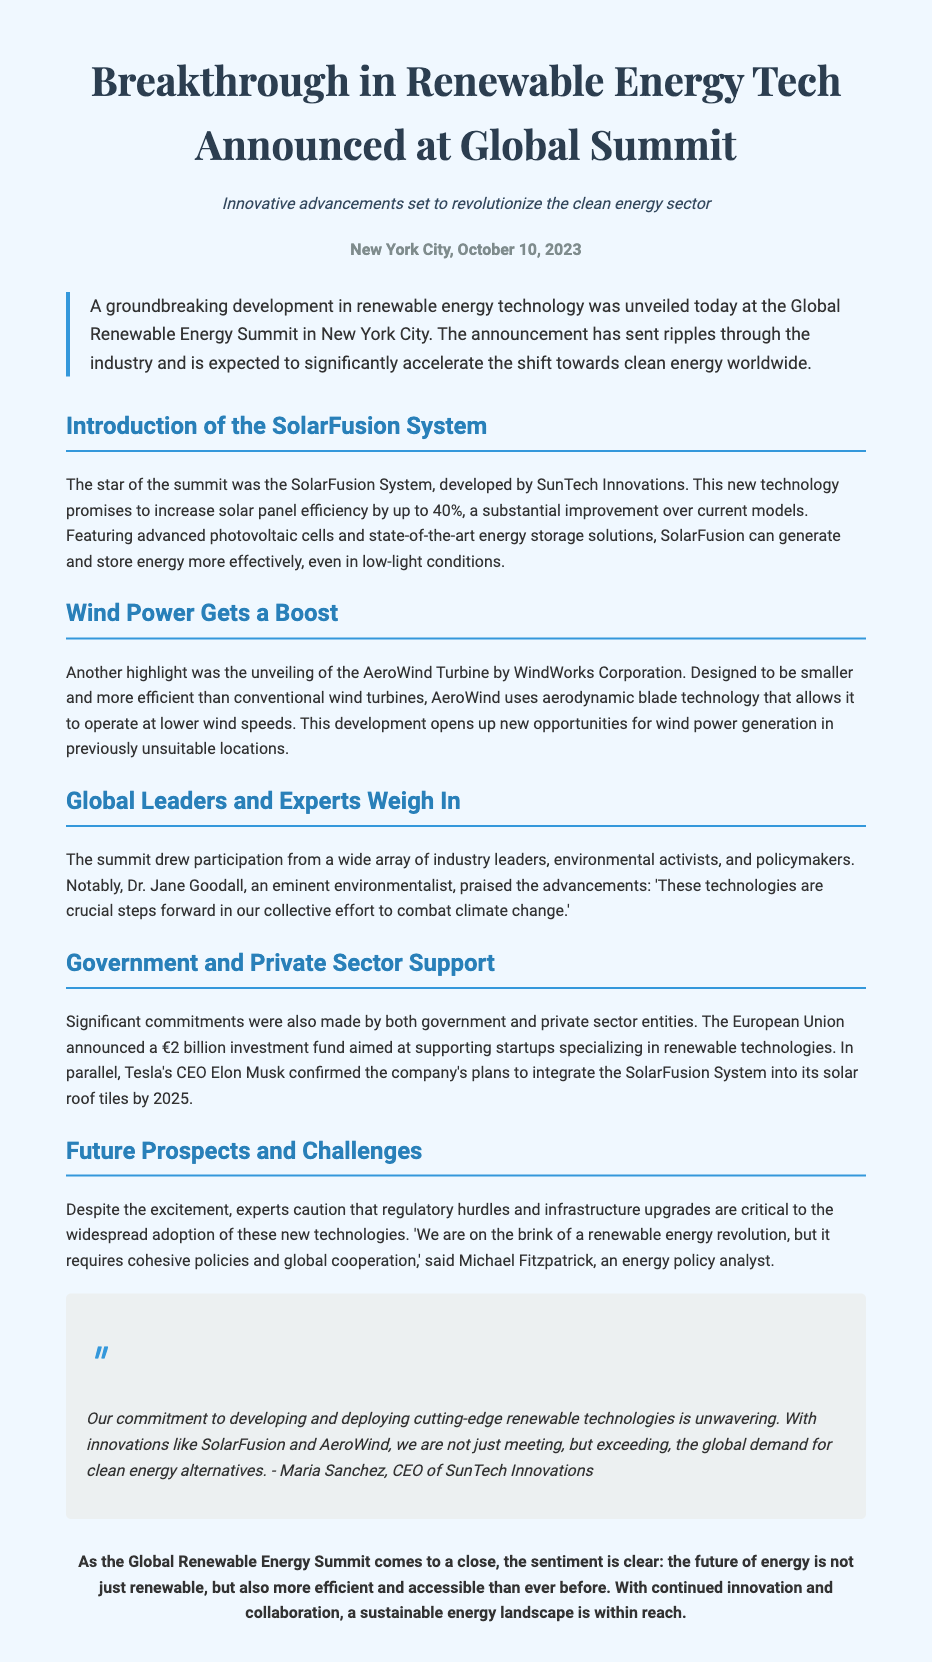What date was the announcement made? The announcement was made on October 10, 2023, as stated in the dateline of the press release.
Answer: October 10, 2023 What is the name of the system developed by SunTech Innovations? The system developed by SunTech Innovations is called the SolarFusion System, mentioned in the introduction section.
Answer: SolarFusion System What is the investment fund announced by the European Union? The European Union announced a €2 billion investment fund aimed at supporting startups specializing in renewable technologies, as noted in the government support section.
Answer: €2 billion Who praised the advancements at the summit? Dr. Jane Goodall praised the advancements, as indicated in the section discussing global leaders.
Answer: Dr. Jane Goodall What efficiency increase does the SolarFusion System promise? The SolarFusion System promises to increase solar panel efficiency by up to 40%, highlighted in its specific section.
Answer: 40% What technology does the AeroWind Turbine utilize? The AeroWind Turbine utilizes aerodynamic blade technology, mentioned in the section focused on wind power.
Answer: Aerodynamic blade technology What is required for the widespread adoption of new technologies, according to experts? Experts state that regulatory hurdles and infrastructure upgrades are critical for widespread adoption, discussed in the future prospects section.
Answer: Regulatory hurdles and infrastructure upgrades What is the overarching sentiment at the conclusion of the summit? The sentiment expressed at the close of the summit is that the future of energy is more efficient and accessible than ever before, as summarized in the closing paragraph.
Answer: More efficient and accessible 